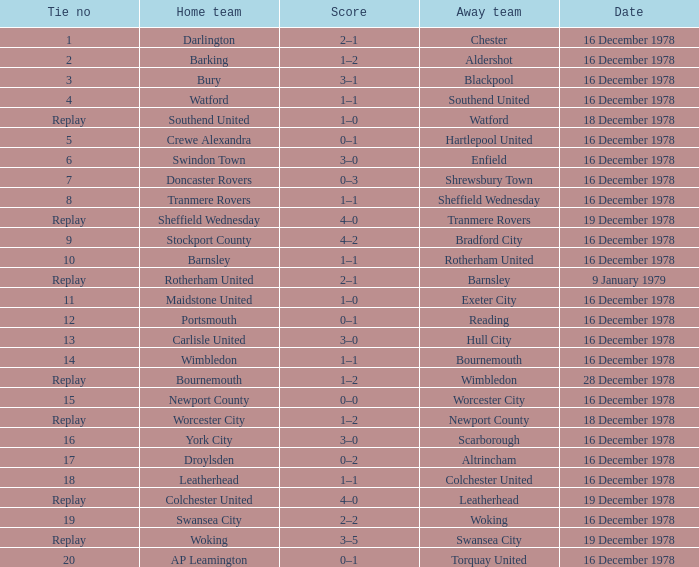What is the score for the date of 16 december 1978, with a tie no of 9? 4–2. 